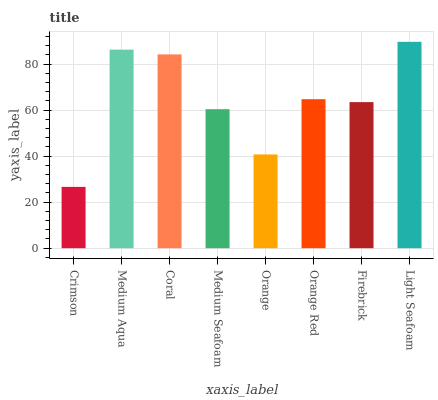Is Crimson the minimum?
Answer yes or no. Yes. Is Light Seafoam the maximum?
Answer yes or no. Yes. Is Medium Aqua the minimum?
Answer yes or no. No. Is Medium Aqua the maximum?
Answer yes or no. No. Is Medium Aqua greater than Crimson?
Answer yes or no. Yes. Is Crimson less than Medium Aqua?
Answer yes or no. Yes. Is Crimson greater than Medium Aqua?
Answer yes or no. No. Is Medium Aqua less than Crimson?
Answer yes or no. No. Is Orange Red the high median?
Answer yes or no. Yes. Is Firebrick the low median?
Answer yes or no. Yes. Is Orange the high median?
Answer yes or no. No. Is Medium Seafoam the low median?
Answer yes or no. No. 